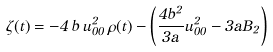<formula> <loc_0><loc_0><loc_500><loc_500>\zeta ( t ) = - 4 \, b \, u _ { 0 0 } ^ { 2 } \, \rho ( t ) - \left ( \frac { 4 b ^ { 2 } } { 3 a } u _ { 0 0 } ^ { 2 } - 3 a B _ { 2 } \right )</formula> 